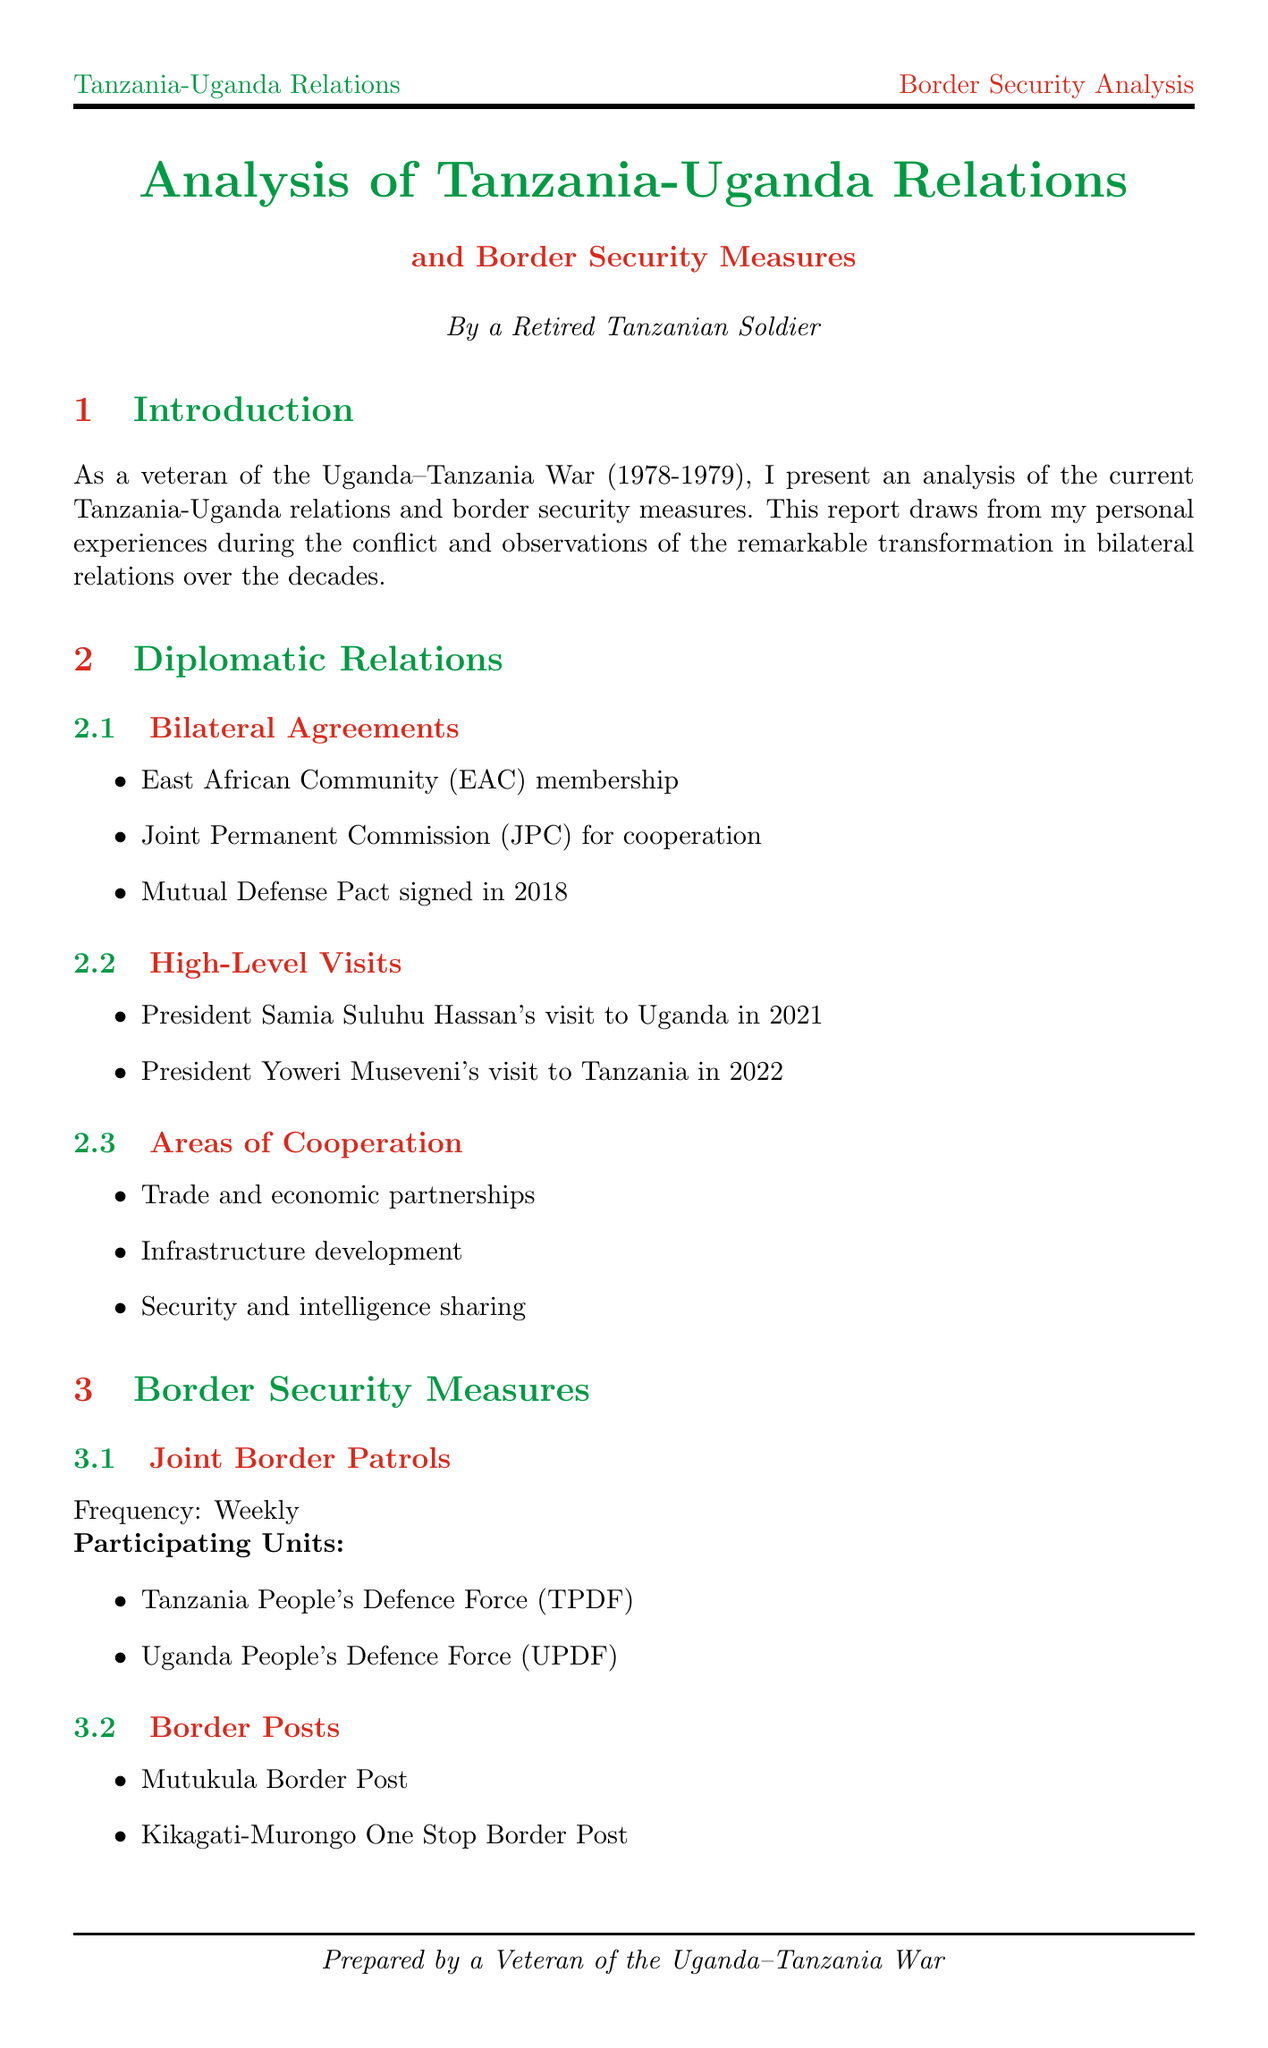What was the historical event discussed in the introduction? The introduction provides a brief overview of the Uganda-Tanzania War, which occurred from 1978 to 1979.
Answer: Uganda-Tanzania War (1978-1979) What is a major export from Tanzania to Uganda? The document lists major exports to Uganda, highlighting items such as maize, rice, and cement.
Answer: Maize Which two countries are involved in joint border patrols? The participating units in the joint border patrols are the Tanzania People's Defence Force and the Uganda People's Defence Force, indicating the collaboration between the two nations.
Answer: Tanzania and Uganda When was the Mutual Defense Pact signed? The document specifies that the Mutual Defense Pact was signed in 2018, providing a timeframe for this agreement.
Answer: 2018 What is one challenge mentioned regarding border security? The report discusses challenges such as border disputes, refugee management, and terrorist threats, which outlines the complexities faced in maintaining security.
Answer: Border disputes What type of technological advancement is used for border security? The document mentions various technological advancements including biometric scanning systems, surveillance cameras, and drone patrols, indicating the integration of technology in border security.
Answer: Biometric scanning systems What area of cooperation is highlighted in diplomatic relations? The document outlines several areas of cooperation, including trade and economic partnerships, emphasizing the collaborative economic efforts between the two countries.
Answer: Trade and economic partnerships What is an area for improvement mentioned for future relations? The report suggests various areas for improvement, emphasizing the need for enhanced intelligence sharing, which is crucial for better collaboration in security matters.
Answer: Enhanced intelligence sharing 